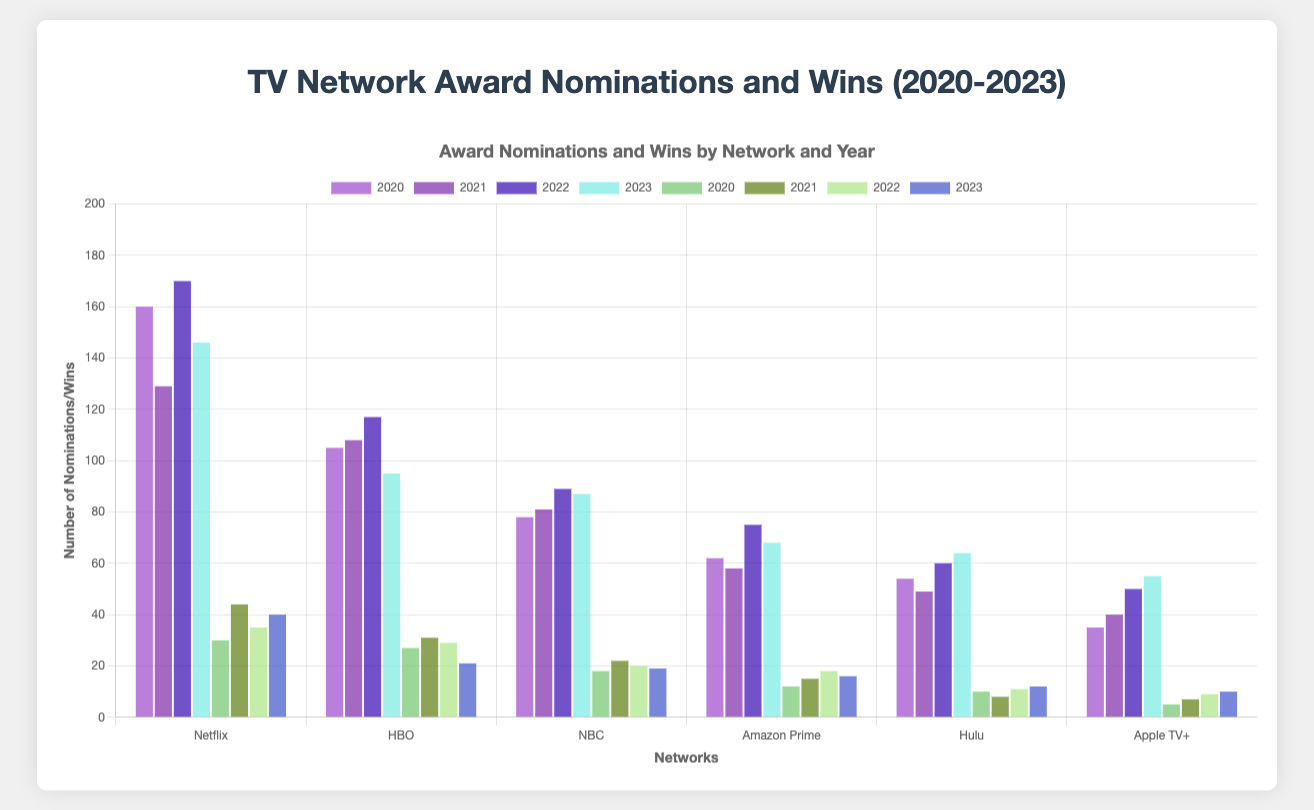Which network had the most nominations in 2020? The height of the bar corresponding to "Nominations" in 2020 is tallest for Netflix, indicating it had the most nominations in 2020.
Answer: Netflix Which network had the least wins in 2021? The shortest bar for "Wins" in 2021 represents Hulu, indicating it had the least wins in 2021.
Answer: Hulu What is the sum of nominations for Hulu over all years? Sum the nominations for Hulu from each year (54 in 2020 + 49 in 2021 + 60 in 2022 + 64 in 2023) to get the total. 54 + 49 + 60 + 64 = 227
Answer: 227 Which network had the greatest increase in wins from 2020 to 2021? Subtract the number of wins in 2020 from the wins in 2021 for each network and find the highest difference. Netflix (44-30) = 14, HBO (31-27) = 4, NBC (22-18) = 4, Amazon Prime (15-12) = 3, Hulu (8-10) = -2, Apple TV+ (7-5) = 2.
Answer: Netflix Compare the wins of HBO in 2022 with the wins of NBC in 2023. Which is higher? The height of the bar for HBO wins in 2022 is higher than the bar for NBC wins in 2023. HBO has 29 wins in 2022, while NBC has 19 wins in 2023.
Answer: HBO How many more nominations did Netflix have compared to Amazon Prime in 2023? Subtract Amazon Prime's nominations in 2023 from Netflix's nominations in 2023. 146 - 68 = 78
Answer: 78 Which network had the highest average number of nominations from 2020 to 2023? Sum the nominations for each network over all years and divide by the number of years (4). Calculate for each network, then compare them. Netflix: (160+129+170+146)/4 = 151.25, HBO: (105+108+117+95)/4 = 106.25, NBC: (78+81+89+87)/4 = 83.75, Amazon Prime: (62+58+75+68)/4 = 65.75, Hulu: (54+49+60+64)/4 = 56.75, Apple TV+: (35+40+50+55)/4 = 45.
Answer: Netflix What is the difference in the total number of wins between Netflix and HBO from 2020 to 2023? Sum the wins for Netflix and HBO from each year and find the difference. Netflix: 30+44+35+40 = 149; HBO: 27+31+29+21 = 108; Difference = 149 - 108 = 41
Answer: 41 How did the nominations for Apple TV+ change from 2021 to 2022? Subtract the nominations for Apple TV+ in 2021 from the nominations in 2022. 50 - 40 = 10
Answer: Increased by 10 